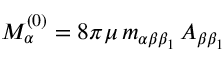Convert formula to latex. <formula><loc_0><loc_0><loc_500><loc_500>M _ { \alpha } ^ { ( 0 ) } = 8 \pi \mu \, m _ { \alpha \beta \beta _ { 1 } } \, A _ { \beta \beta _ { 1 } }</formula> 